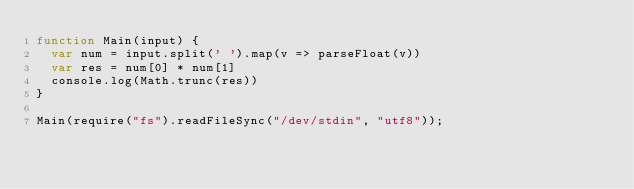<code> <loc_0><loc_0><loc_500><loc_500><_JavaScript_>function Main(input) {
  var num = input.split(' ').map(v => parseFloat(v))
  var res = num[0] * num[1]
  console.log(Math.trunc(res))
}

Main(require("fs").readFileSync("/dev/stdin", "utf8"));</code> 